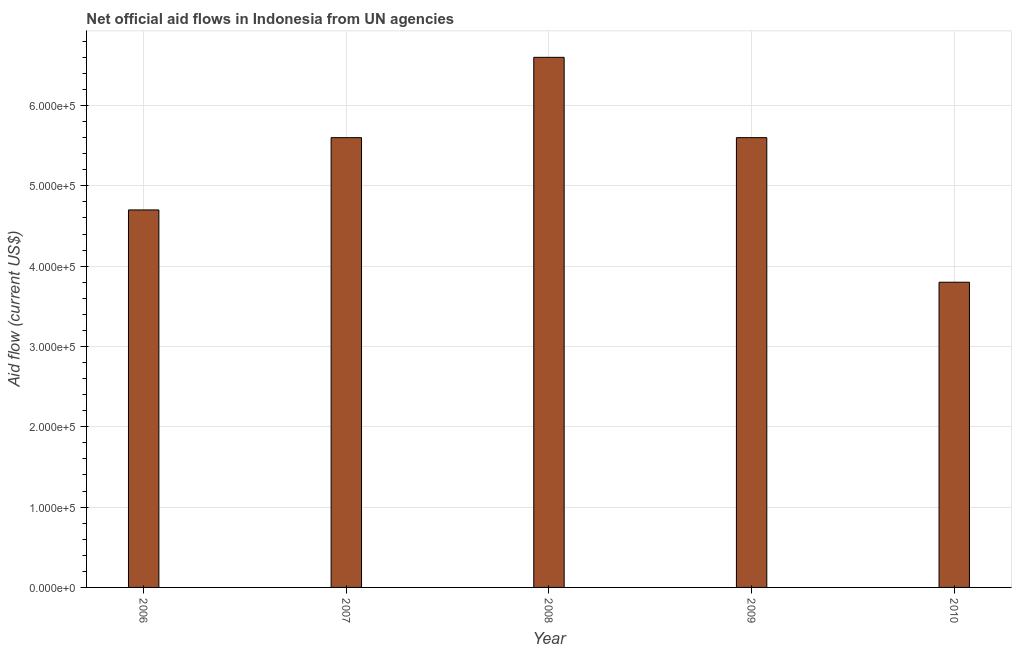Does the graph contain any zero values?
Make the answer very short. No. What is the title of the graph?
Keep it short and to the point. Net official aid flows in Indonesia from UN agencies. What is the label or title of the X-axis?
Offer a very short reply. Year. What is the label or title of the Y-axis?
Provide a succinct answer. Aid flow (current US$). Across all years, what is the minimum net official flows from un agencies?
Ensure brevity in your answer.  3.80e+05. In which year was the net official flows from un agencies maximum?
Provide a short and direct response. 2008. In which year was the net official flows from un agencies minimum?
Your answer should be compact. 2010. What is the sum of the net official flows from un agencies?
Your answer should be very brief. 2.63e+06. What is the difference between the net official flows from un agencies in 2006 and 2007?
Your response must be concise. -9.00e+04. What is the average net official flows from un agencies per year?
Offer a very short reply. 5.26e+05. What is the median net official flows from un agencies?
Give a very brief answer. 5.60e+05. In how many years, is the net official flows from un agencies greater than 400000 US$?
Offer a very short reply. 4. Do a majority of the years between 2008 and 2010 (inclusive) have net official flows from un agencies greater than 140000 US$?
Provide a succinct answer. Yes. What is the ratio of the net official flows from un agencies in 2008 to that in 2010?
Provide a succinct answer. 1.74. Is the net official flows from un agencies in 2006 less than that in 2008?
Give a very brief answer. Yes. Is the sum of the net official flows from un agencies in 2006 and 2009 greater than the maximum net official flows from un agencies across all years?
Keep it short and to the point. Yes. What is the difference between the highest and the lowest net official flows from un agencies?
Keep it short and to the point. 2.80e+05. How many bars are there?
Your answer should be very brief. 5. Are all the bars in the graph horizontal?
Keep it short and to the point. No. How many years are there in the graph?
Give a very brief answer. 5. What is the difference between two consecutive major ticks on the Y-axis?
Your answer should be very brief. 1.00e+05. What is the Aid flow (current US$) in 2006?
Make the answer very short. 4.70e+05. What is the Aid flow (current US$) of 2007?
Your answer should be compact. 5.60e+05. What is the Aid flow (current US$) of 2008?
Your response must be concise. 6.60e+05. What is the Aid flow (current US$) of 2009?
Provide a short and direct response. 5.60e+05. What is the difference between the Aid flow (current US$) in 2006 and 2007?
Make the answer very short. -9.00e+04. What is the difference between the Aid flow (current US$) in 2006 and 2010?
Offer a very short reply. 9.00e+04. What is the difference between the Aid flow (current US$) in 2007 and 2008?
Your response must be concise. -1.00e+05. What is the difference between the Aid flow (current US$) in 2008 and 2009?
Your answer should be compact. 1.00e+05. What is the difference between the Aid flow (current US$) in 2008 and 2010?
Your answer should be compact. 2.80e+05. What is the ratio of the Aid flow (current US$) in 2006 to that in 2007?
Your answer should be compact. 0.84. What is the ratio of the Aid flow (current US$) in 2006 to that in 2008?
Keep it short and to the point. 0.71. What is the ratio of the Aid flow (current US$) in 2006 to that in 2009?
Provide a short and direct response. 0.84. What is the ratio of the Aid flow (current US$) in 2006 to that in 2010?
Offer a very short reply. 1.24. What is the ratio of the Aid flow (current US$) in 2007 to that in 2008?
Ensure brevity in your answer.  0.85. What is the ratio of the Aid flow (current US$) in 2007 to that in 2010?
Offer a terse response. 1.47. What is the ratio of the Aid flow (current US$) in 2008 to that in 2009?
Offer a terse response. 1.18. What is the ratio of the Aid flow (current US$) in 2008 to that in 2010?
Provide a succinct answer. 1.74. What is the ratio of the Aid flow (current US$) in 2009 to that in 2010?
Ensure brevity in your answer.  1.47. 